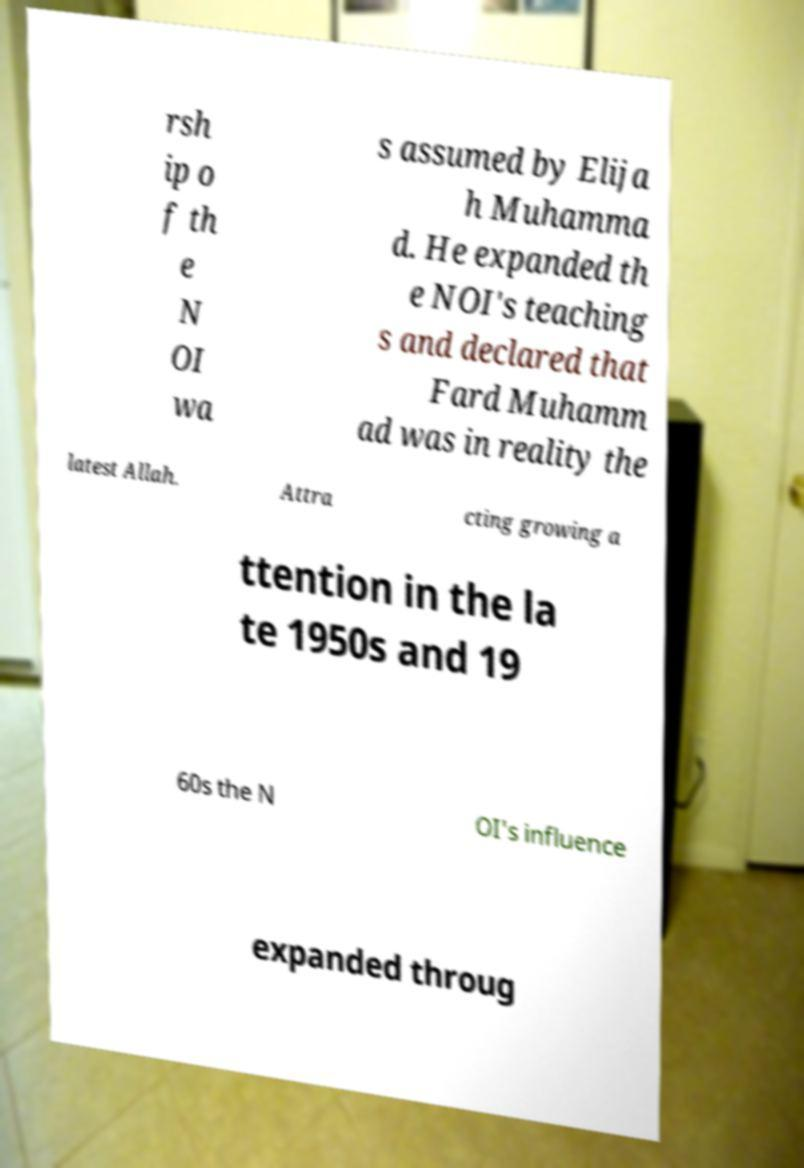I need the written content from this picture converted into text. Can you do that? rsh ip o f th e N OI wa s assumed by Elija h Muhamma d. He expanded th e NOI's teaching s and declared that Fard Muhamm ad was in reality the latest Allah. Attra cting growing a ttention in the la te 1950s and 19 60s the N OI's influence expanded throug 